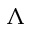Convert formula to latex. <formula><loc_0><loc_0><loc_500><loc_500>\Lambda</formula> 